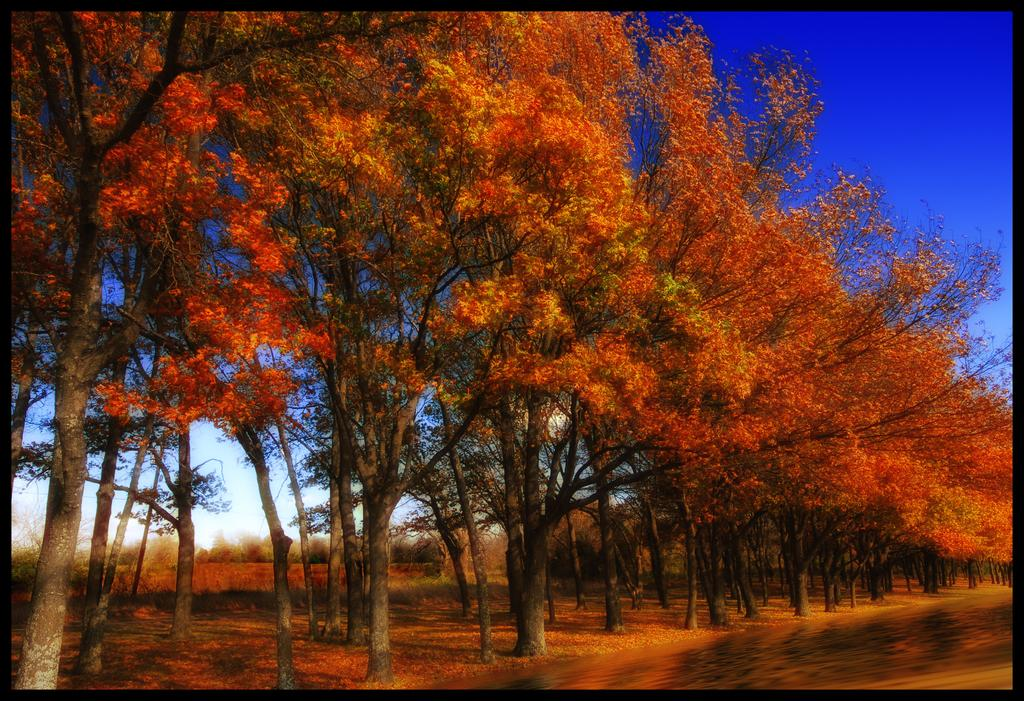What type of trees are in the image? There are colorful trees in the image. What other natural elements can be seen in the image? There is grass in the image. What is visible in the background of the image? The sky is visible in the background of the image. What is the color of the sky in the image? The color of the sky is blue. How does the baby tie a knot in the image? There is no baby or knot present in the image. What type of nerve is visible in the image? There are no nerves visible in the image; it features colorful trees, grass, and a blue sky. 